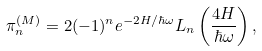<formula> <loc_0><loc_0><loc_500><loc_500>\pi _ { n } ^ { ( M ) } = 2 ( - 1 ) ^ { n } e ^ { - 2 H / \hbar { \omega } } L _ { n } \left ( \frac { 4 H } { \hbar { \omega } } \right ) ,</formula> 